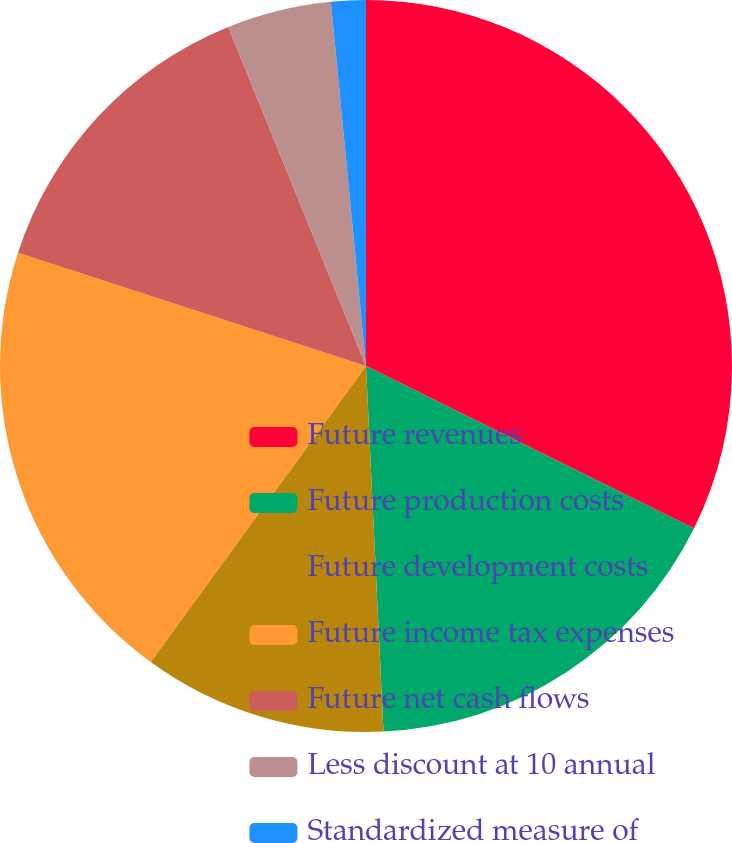<chart> <loc_0><loc_0><loc_500><loc_500><pie_chart><fcel>Future revenues<fcel>Future production costs<fcel>Future development costs<fcel>Future income tax expenses<fcel>Future net cash flows<fcel>Less discount at 10 annual<fcel>Standardized measure of<nl><fcel>32.32%<fcel>16.92%<fcel>10.77%<fcel>20.0%<fcel>13.85%<fcel>4.61%<fcel>1.53%<nl></chart> 